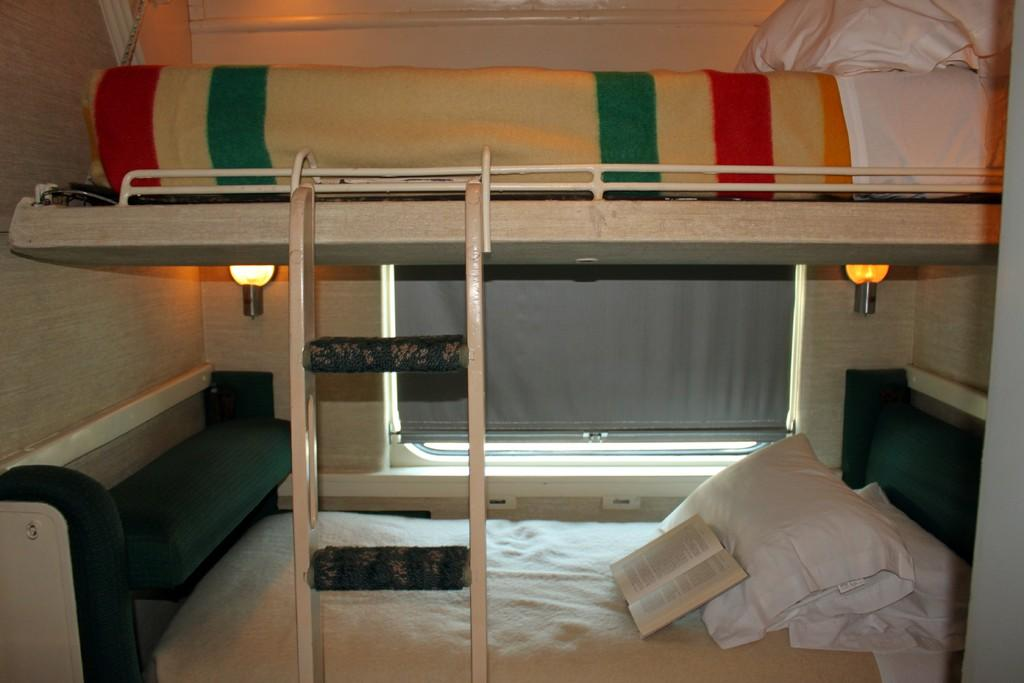What type of furniture is in the image? There is a double cot and two beds in the image. What accessories are on the beds? There are pillows and blankets on the beds. Is there any reading material on the beds? Yes, there is a book on one of the beds. What can be seen in the background of the image? There is a light, a window, and a wood wall in the background of the image. What type of chicken can be seen roaming around in the image? There is no chicken present in the image. How does the acoustics of the room affect the sound quality in the image? The image does not provide any information about the acoustics of the room, so it cannot be determined how they affect the sound quality. 